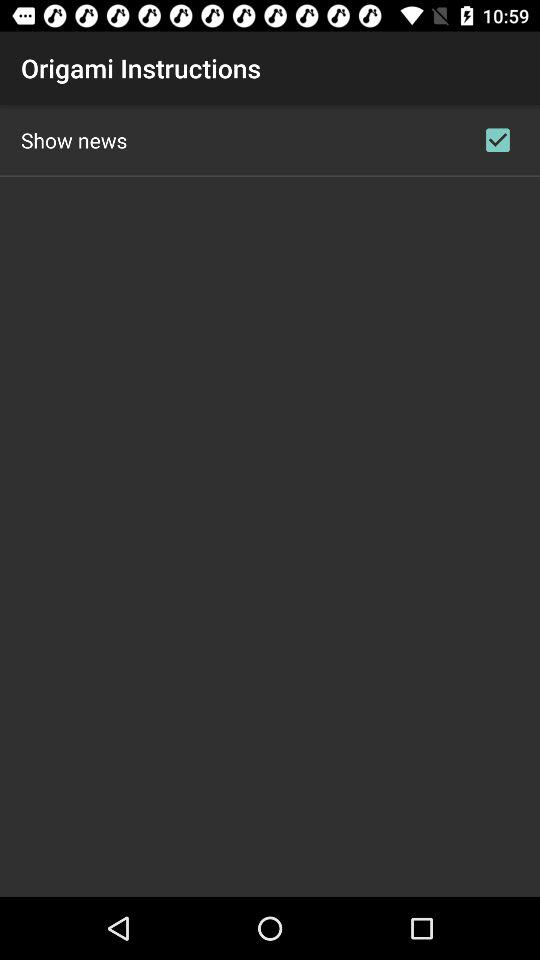What is the status of "Show news"? The status of "Show news" is "on". 